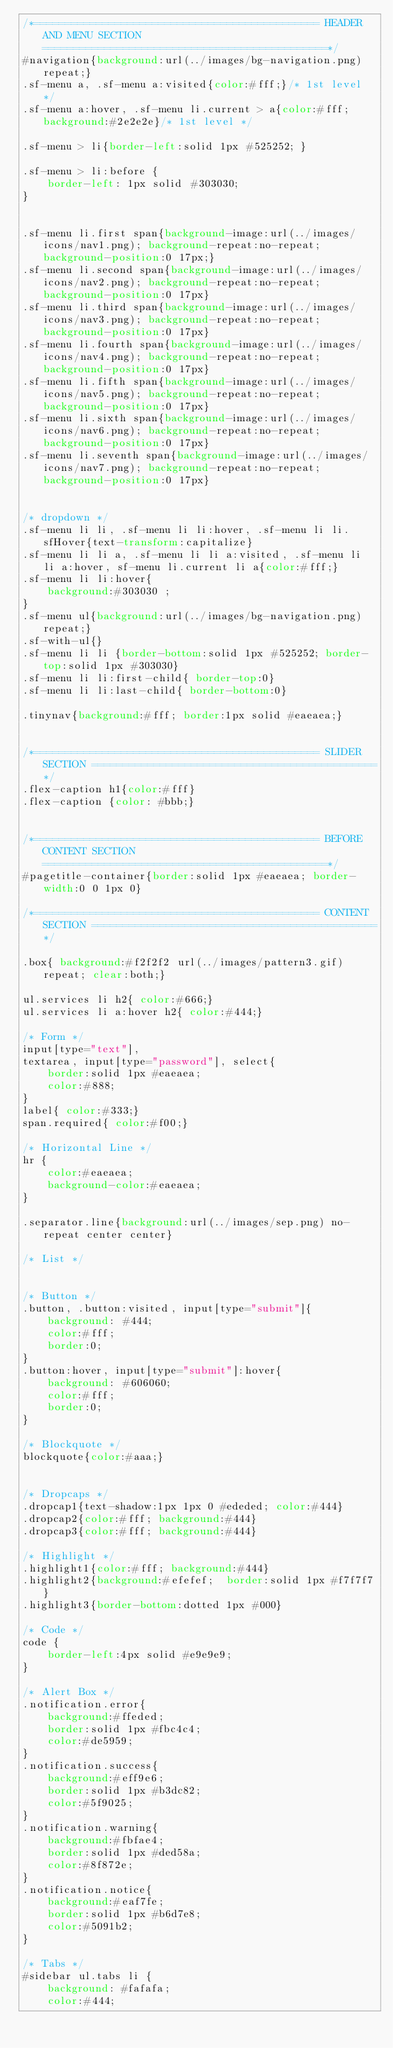Convert code to text. <code><loc_0><loc_0><loc_500><loc_500><_CSS_>/*============================================== HEADER AND MENU SECTION ==============================================*/
#navigation{background:url(../images/bg-navigation.png) repeat;}
.sf-menu a, .sf-menu a:visited{color:#fff;}/* 1st level */
.sf-menu a:hover, .sf-menu li.current > a{color:#fff; background:#2e2e2e}/* 1st level */

.sf-menu > li{border-left:solid 1px #525252; }

.sf-menu > li:before {
    border-left: 1px solid #303030;
}


.sf-menu li.first span{background-image:url(../images/icons/nav1.png); background-repeat:no-repeat; background-position:0 17px;}
.sf-menu li.second span{background-image:url(../images/icons/nav2.png); background-repeat:no-repeat; background-position:0 17px}
.sf-menu li.third span{background-image:url(../images/icons/nav3.png); background-repeat:no-repeat; background-position:0 17px}
.sf-menu li.fourth span{background-image:url(../images/icons/nav4.png); background-repeat:no-repeat; background-position:0 17px}
.sf-menu li.fifth span{background-image:url(../images/icons/nav5.png); background-repeat:no-repeat; background-position:0 17px}
.sf-menu li.sixth span{background-image:url(../images/icons/nav6.png); background-repeat:no-repeat; background-position:0 17px}
.sf-menu li.seventh span{background-image:url(../images/icons/nav7.png); background-repeat:no-repeat; background-position:0 17px}


/* dropdown */
.sf-menu li li, .sf-menu li li:hover, .sf-menu li li.sfHover{text-transform:capitalize}
.sf-menu li li a, .sf-menu li li a:visited, .sf-menu li li a:hover, sf-menu li.current li a{color:#fff;}
.sf-menu li li:hover{
	background:#303030 ;
}
.sf-menu ul{background:url(../images/bg-navigation.png) repeat;}
.sf-with-ul{}
.sf-menu li li {border-bottom:solid 1px #525252; border-top:solid 1px #303030}
.sf-menu li li:first-child{ border-top:0}
.sf-menu li li:last-child{ border-bottom:0}

.tinynav{background:#fff; border:1px solid #eaeaea;}


/*============================================== SLIDER SECTION ==============================================*/
.flex-caption h1{color:#fff}
.flex-caption {color: #bbb;}


/*============================================== BEFORE CONTENT SECTION ==============================================*/
#pagetitle-container{border:solid 1px #eaeaea; border-width:0 0 1px 0} 

/*============================================== CONTENT SECTION ==============================================*/

.box{ background:#f2f2f2 url(../images/pattern3.gif) repeat; clear:both;}

ul.services li h2{ color:#666;}
ul.services li a:hover h2{ color:#444;}

/* Form */
input[type="text"],
textarea, input[type="password"], select{
	border:solid 1px #eaeaea;
	color:#888;
}
label{ color:#333;}
span.required{ color:#f00;}

/* Horizontal Line */
hr {
	color:#eaeaea;
	background-color:#eaeaea;
}

.separator.line{background:url(../images/sep.png) no-repeat center center}

/* List */


/* Button */
.button, .button:visited, input[type="submit"]{
	background: #444;
	color:#fff;
	border:0;
}
.button:hover, input[type="submit"]:hover{
	background: #606060;
	color:#fff;
	border:0;
}

/* Blockquote */
blockquote{color:#aaa;}


/* Dropcaps */	
.dropcap1{text-shadow:1px 1px 0 #ededed; color:#444}
.dropcap2{color:#fff; background:#444}		
.dropcap3{color:#fff; background:#444}

/* Highlight */
.highlight1{color:#fff; background:#444}	
.highlight2{background:#efefef;  border:solid 1px #f7f7f7}
.highlight3{border-bottom:dotted 1px #000}

/* Code */
code {
	border-left:4px solid #e9e9e9;
}

/* Alert Box */
.notification.error{
	background:#ffeded;
	border:solid 1px #fbc4c4;
	color:#de5959;	
}
.notification.success{
	background:#eff9e6;
	border:solid 1px #b3dc82;
	color:#5f9025;	
}
.notification.warning{
	background:#fbfae4;
	border:solid 1px #ded58a;
	color:#8f872e;	
}
.notification.notice{
	background:#eaf7fe;
	border:solid 1px #b6d7e8;
	color:#5091b2;	
}
		
/* Tabs */
#sidebar ul.tabs li {
	background: #fafafa;
	color:#444;</code> 